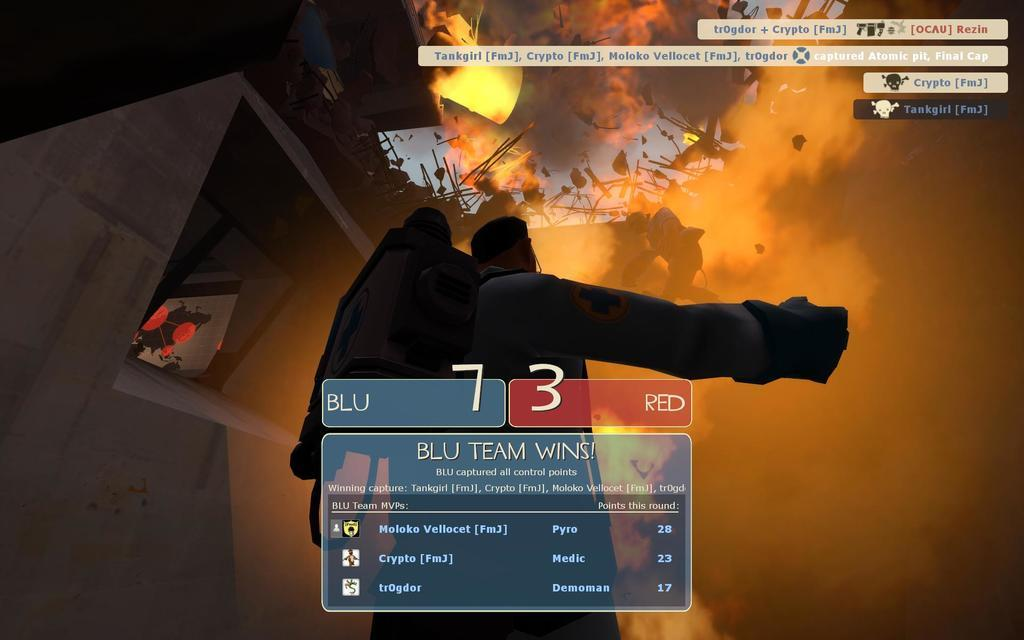<image>
Present a compact description of the photo's key features. A video game on a screen that says Blu Team Wins with a score of 7 to 3 and a person walking with fire behind them. 